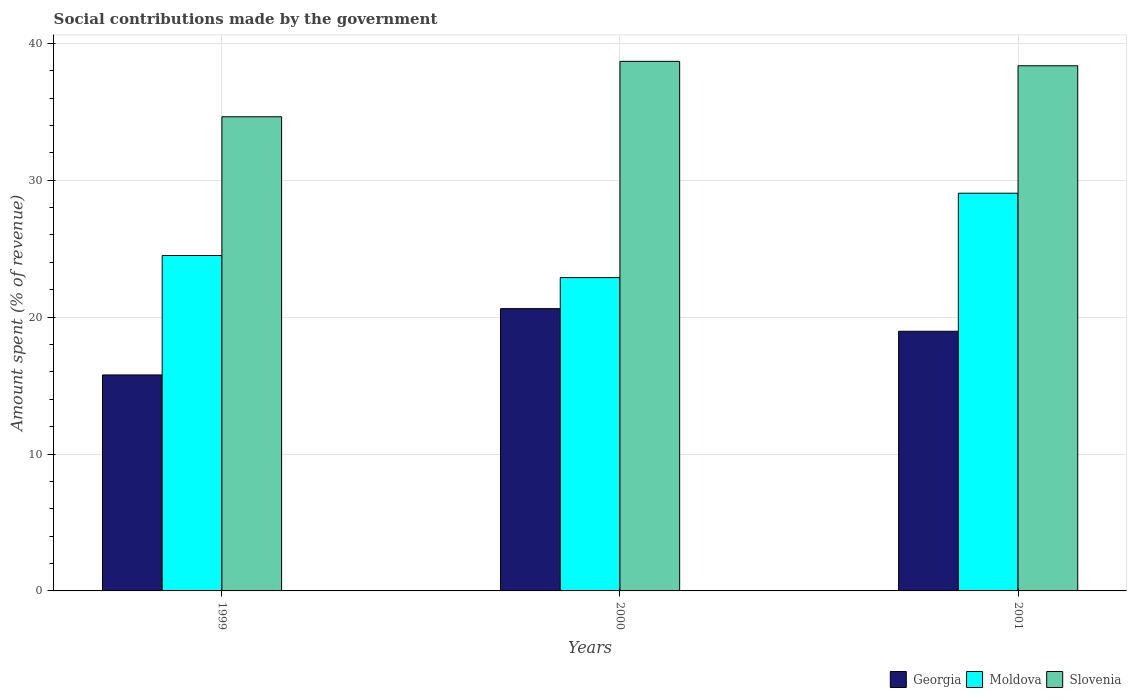Are the number of bars per tick equal to the number of legend labels?
Give a very brief answer. Yes. Are the number of bars on each tick of the X-axis equal?
Give a very brief answer. Yes. How many bars are there on the 2nd tick from the left?
Offer a terse response. 3. How many bars are there on the 3rd tick from the right?
Keep it short and to the point. 3. In how many cases, is the number of bars for a given year not equal to the number of legend labels?
Your answer should be very brief. 0. What is the amount spent (in %) on social contributions in Moldova in 1999?
Your response must be concise. 24.5. Across all years, what is the maximum amount spent (in %) on social contributions in Georgia?
Your response must be concise. 20.62. Across all years, what is the minimum amount spent (in %) on social contributions in Georgia?
Keep it short and to the point. 15.78. In which year was the amount spent (in %) on social contributions in Moldova minimum?
Your answer should be very brief. 2000. What is the total amount spent (in %) on social contributions in Georgia in the graph?
Provide a short and direct response. 55.36. What is the difference between the amount spent (in %) on social contributions in Georgia in 2000 and that in 2001?
Ensure brevity in your answer.  1.65. What is the difference between the amount spent (in %) on social contributions in Georgia in 2001 and the amount spent (in %) on social contributions in Slovenia in 1999?
Provide a succinct answer. -15.67. What is the average amount spent (in %) on social contributions in Moldova per year?
Provide a short and direct response. 25.48. In the year 2000, what is the difference between the amount spent (in %) on social contributions in Georgia and amount spent (in %) on social contributions in Moldova?
Provide a short and direct response. -2.27. What is the ratio of the amount spent (in %) on social contributions in Georgia in 1999 to that in 2000?
Ensure brevity in your answer.  0.77. Is the difference between the amount spent (in %) on social contributions in Georgia in 1999 and 2000 greater than the difference between the amount spent (in %) on social contributions in Moldova in 1999 and 2000?
Ensure brevity in your answer.  No. What is the difference between the highest and the second highest amount spent (in %) on social contributions in Slovenia?
Ensure brevity in your answer.  0.32. What is the difference between the highest and the lowest amount spent (in %) on social contributions in Georgia?
Offer a very short reply. 4.84. What does the 2nd bar from the left in 2001 represents?
Make the answer very short. Moldova. What does the 2nd bar from the right in 1999 represents?
Your response must be concise. Moldova. Is it the case that in every year, the sum of the amount spent (in %) on social contributions in Slovenia and amount spent (in %) on social contributions in Georgia is greater than the amount spent (in %) on social contributions in Moldova?
Provide a succinct answer. Yes. Are all the bars in the graph horizontal?
Provide a succinct answer. No. Are the values on the major ticks of Y-axis written in scientific E-notation?
Your answer should be very brief. No. Does the graph contain any zero values?
Keep it short and to the point. No. Does the graph contain grids?
Offer a very short reply. Yes. Where does the legend appear in the graph?
Provide a short and direct response. Bottom right. How many legend labels are there?
Keep it short and to the point. 3. How are the legend labels stacked?
Provide a short and direct response. Horizontal. What is the title of the graph?
Offer a very short reply. Social contributions made by the government. What is the label or title of the Y-axis?
Provide a succinct answer. Amount spent (% of revenue). What is the Amount spent (% of revenue) in Georgia in 1999?
Ensure brevity in your answer.  15.78. What is the Amount spent (% of revenue) in Moldova in 1999?
Offer a terse response. 24.5. What is the Amount spent (% of revenue) of Slovenia in 1999?
Your answer should be compact. 34.63. What is the Amount spent (% of revenue) of Georgia in 2000?
Provide a short and direct response. 20.62. What is the Amount spent (% of revenue) of Moldova in 2000?
Ensure brevity in your answer.  22.89. What is the Amount spent (% of revenue) of Slovenia in 2000?
Give a very brief answer. 38.68. What is the Amount spent (% of revenue) in Georgia in 2001?
Provide a short and direct response. 18.97. What is the Amount spent (% of revenue) in Moldova in 2001?
Give a very brief answer. 29.05. What is the Amount spent (% of revenue) of Slovenia in 2001?
Provide a short and direct response. 38.36. Across all years, what is the maximum Amount spent (% of revenue) of Georgia?
Keep it short and to the point. 20.62. Across all years, what is the maximum Amount spent (% of revenue) in Moldova?
Keep it short and to the point. 29.05. Across all years, what is the maximum Amount spent (% of revenue) of Slovenia?
Offer a terse response. 38.68. Across all years, what is the minimum Amount spent (% of revenue) of Georgia?
Keep it short and to the point. 15.78. Across all years, what is the minimum Amount spent (% of revenue) of Moldova?
Your answer should be very brief. 22.89. Across all years, what is the minimum Amount spent (% of revenue) in Slovenia?
Make the answer very short. 34.63. What is the total Amount spent (% of revenue) in Georgia in the graph?
Keep it short and to the point. 55.36. What is the total Amount spent (% of revenue) in Moldova in the graph?
Offer a very short reply. 76.43. What is the total Amount spent (% of revenue) in Slovenia in the graph?
Offer a terse response. 111.67. What is the difference between the Amount spent (% of revenue) of Georgia in 1999 and that in 2000?
Ensure brevity in your answer.  -4.84. What is the difference between the Amount spent (% of revenue) of Moldova in 1999 and that in 2000?
Your answer should be very brief. 1.61. What is the difference between the Amount spent (% of revenue) in Slovenia in 1999 and that in 2000?
Offer a very short reply. -4.05. What is the difference between the Amount spent (% of revenue) of Georgia in 1999 and that in 2001?
Provide a short and direct response. -3.19. What is the difference between the Amount spent (% of revenue) of Moldova in 1999 and that in 2001?
Your answer should be very brief. -4.55. What is the difference between the Amount spent (% of revenue) of Slovenia in 1999 and that in 2001?
Provide a short and direct response. -3.72. What is the difference between the Amount spent (% of revenue) of Georgia in 2000 and that in 2001?
Provide a succinct answer. 1.65. What is the difference between the Amount spent (% of revenue) in Moldova in 2000 and that in 2001?
Your answer should be compact. -6.16. What is the difference between the Amount spent (% of revenue) of Slovenia in 2000 and that in 2001?
Give a very brief answer. 0.32. What is the difference between the Amount spent (% of revenue) in Georgia in 1999 and the Amount spent (% of revenue) in Moldova in 2000?
Your response must be concise. -7.11. What is the difference between the Amount spent (% of revenue) of Georgia in 1999 and the Amount spent (% of revenue) of Slovenia in 2000?
Offer a terse response. -22.91. What is the difference between the Amount spent (% of revenue) of Moldova in 1999 and the Amount spent (% of revenue) of Slovenia in 2000?
Your response must be concise. -14.18. What is the difference between the Amount spent (% of revenue) in Georgia in 1999 and the Amount spent (% of revenue) in Moldova in 2001?
Ensure brevity in your answer.  -13.27. What is the difference between the Amount spent (% of revenue) of Georgia in 1999 and the Amount spent (% of revenue) of Slovenia in 2001?
Your response must be concise. -22.58. What is the difference between the Amount spent (% of revenue) of Moldova in 1999 and the Amount spent (% of revenue) of Slovenia in 2001?
Offer a terse response. -13.86. What is the difference between the Amount spent (% of revenue) of Georgia in 2000 and the Amount spent (% of revenue) of Moldova in 2001?
Provide a short and direct response. -8.43. What is the difference between the Amount spent (% of revenue) of Georgia in 2000 and the Amount spent (% of revenue) of Slovenia in 2001?
Your answer should be compact. -17.74. What is the difference between the Amount spent (% of revenue) of Moldova in 2000 and the Amount spent (% of revenue) of Slovenia in 2001?
Offer a very short reply. -15.47. What is the average Amount spent (% of revenue) of Georgia per year?
Give a very brief answer. 18.45. What is the average Amount spent (% of revenue) of Moldova per year?
Offer a terse response. 25.48. What is the average Amount spent (% of revenue) in Slovenia per year?
Your response must be concise. 37.22. In the year 1999, what is the difference between the Amount spent (% of revenue) of Georgia and Amount spent (% of revenue) of Moldova?
Provide a succinct answer. -8.72. In the year 1999, what is the difference between the Amount spent (% of revenue) in Georgia and Amount spent (% of revenue) in Slovenia?
Give a very brief answer. -18.86. In the year 1999, what is the difference between the Amount spent (% of revenue) in Moldova and Amount spent (% of revenue) in Slovenia?
Your answer should be very brief. -10.13. In the year 2000, what is the difference between the Amount spent (% of revenue) of Georgia and Amount spent (% of revenue) of Moldova?
Make the answer very short. -2.27. In the year 2000, what is the difference between the Amount spent (% of revenue) in Georgia and Amount spent (% of revenue) in Slovenia?
Ensure brevity in your answer.  -18.06. In the year 2000, what is the difference between the Amount spent (% of revenue) of Moldova and Amount spent (% of revenue) of Slovenia?
Your answer should be very brief. -15.8. In the year 2001, what is the difference between the Amount spent (% of revenue) of Georgia and Amount spent (% of revenue) of Moldova?
Make the answer very short. -10.08. In the year 2001, what is the difference between the Amount spent (% of revenue) of Georgia and Amount spent (% of revenue) of Slovenia?
Your response must be concise. -19.39. In the year 2001, what is the difference between the Amount spent (% of revenue) of Moldova and Amount spent (% of revenue) of Slovenia?
Make the answer very short. -9.31. What is the ratio of the Amount spent (% of revenue) in Georgia in 1999 to that in 2000?
Provide a succinct answer. 0.77. What is the ratio of the Amount spent (% of revenue) in Moldova in 1999 to that in 2000?
Keep it short and to the point. 1.07. What is the ratio of the Amount spent (% of revenue) in Slovenia in 1999 to that in 2000?
Offer a very short reply. 0.9. What is the ratio of the Amount spent (% of revenue) in Georgia in 1999 to that in 2001?
Offer a terse response. 0.83. What is the ratio of the Amount spent (% of revenue) in Moldova in 1999 to that in 2001?
Your response must be concise. 0.84. What is the ratio of the Amount spent (% of revenue) of Slovenia in 1999 to that in 2001?
Ensure brevity in your answer.  0.9. What is the ratio of the Amount spent (% of revenue) in Georgia in 2000 to that in 2001?
Provide a succinct answer. 1.09. What is the ratio of the Amount spent (% of revenue) in Moldova in 2000 to that in 2001?
Give a very brief answer. 0.79. What is the ratio of the Amount spent (% of revenue) of Slovenia in 2000 to that in 2001?
Your answer should be compact. 1.01. What is the difference between the highest and the second highest Amount spent (% of revenue) of Georgia?
Your answer should be very brief. 1.65. What is the difference between the highest and the second highest Amount spent (% of revenue) in Moldova?
Provide a short and direct response. 4.55. What is the difference between the highest and the second highest Amount spent (% of revenue) of Slovenia?
Your answer should be compact. 0.32. What is the difference between the highest and the lowest Amount spent (% of revenue) of Georgia?
Provide a short and direct response. 4.84. What is the difference between the highest and the lowest Amount spent (% of revenue) of Moldova?
Ensure brevity in your answer.  6.16. What is the difference between the highest and the lowest Amount spent (% of revenue) in Slovenia?
Your answer should be very brief. 4.05. 